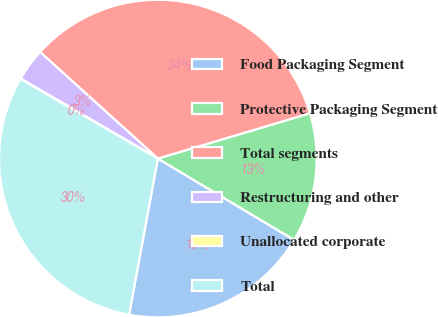Convert chart to OTSL. <chart><loc_0><loc_0><loc_500><loc_500><pie_chart><fcel>Food Packaging Segment<fcel>Protective Packaging Segment<fcel>Total segments<fcel>Restructuring and other<fcel>Unallocated corporate<fcel>Total<nl><fcel>19.33%<fcel>13.17%<fcel>33.69%<fcel>3.3%<fcel>0.05%<fcel>30.45%<nl></chart> 